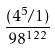Convert formula to latex. <formula><loc_0><loc_0><loc_500><loc_500>\frac { ( 4 ^ { 5 } / 1 ) } { 9 8 ^ { 1 2 2 } }</formula> 